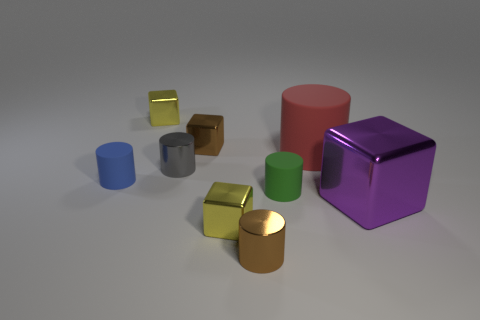What is the big red cylinder made of?
Ensure brevity in your answer.  Rubber. What number of things are large brown matte things or purple blocks?
Ensure brevity in your answer.  1. There is a brown object behind the big purple metal cube; what is its size?
Provide a short and direct response. Small. What number of other objects are there of the same material as the small brown cylinder?
Offer a terse response. 5. Are there any brown objects in front of the small brown object in front of the tiny brown shiny block?
Your answer should be very brief. No. Is there any other thing that is the same shape as the big red rubber object?
Provide a short and direct response. Yes. The other tiny rubber object that is the same shape as the blue matte thing is what color?
Offer a terse response. Green. How big is the brown cylinder?
Offer a very short reply. Small. Is the number of green rubber things behind the big matte object less than the number of small yellow rubber cylinders?
Give a very brief answer. No. Is the material of the tiny blue cylinder the same as the yellow cube that is behind the blue object?
Your answer should be compact. No. 